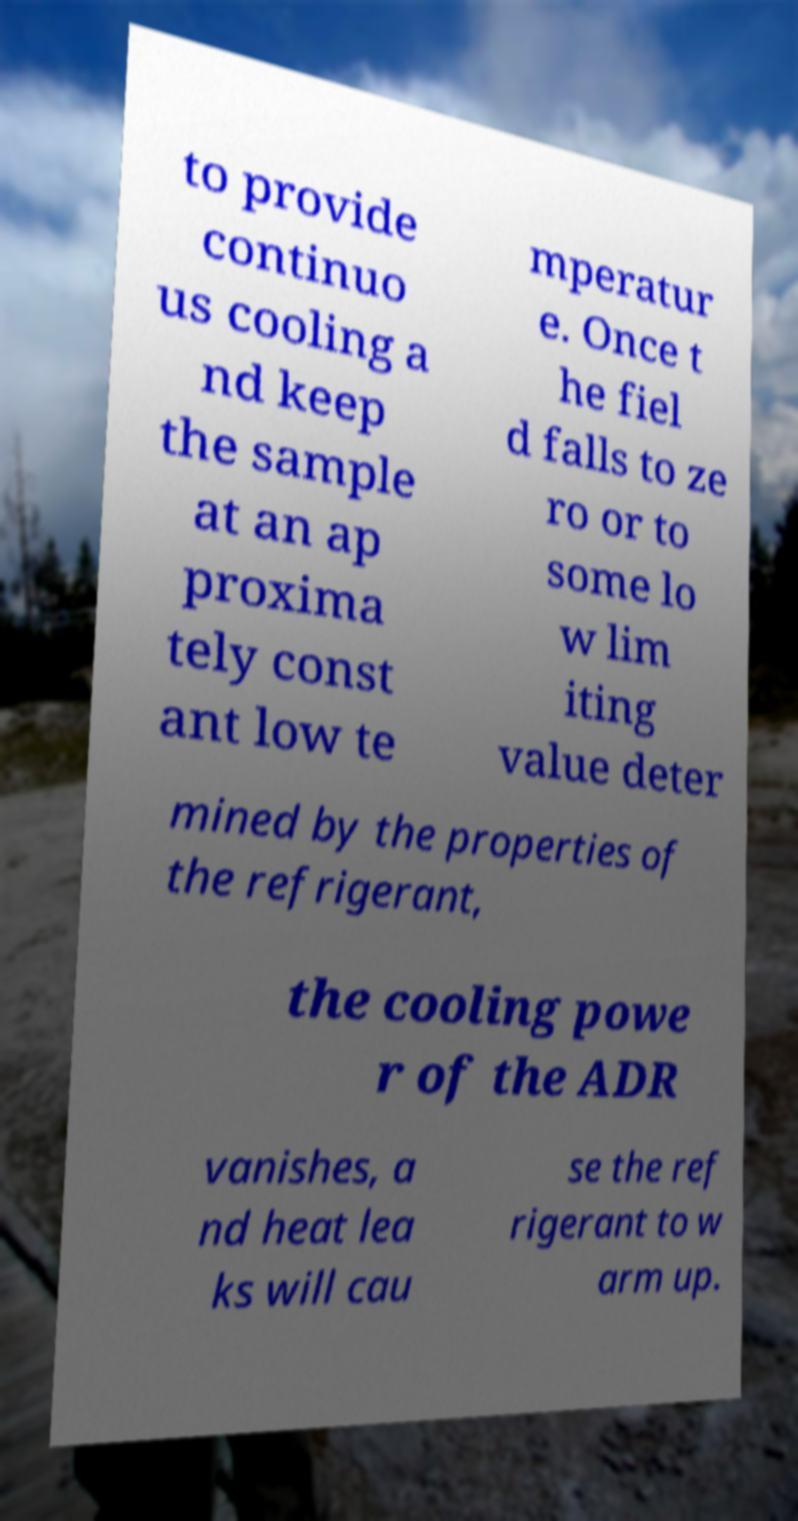Can you accurately transcribe the text from the provided image for me? to provide continuo us cooling a nd keep the sample at an ap proxima tely const ant low te mperatur e. Once t he fiel d falls to ze ro or to some lo w lim iting value deter mined by the properties of the refrigerant, the cooling powe r of the ADR vanishes, a nd heat lea ks will cau se the ref rigerant to w arm up. 